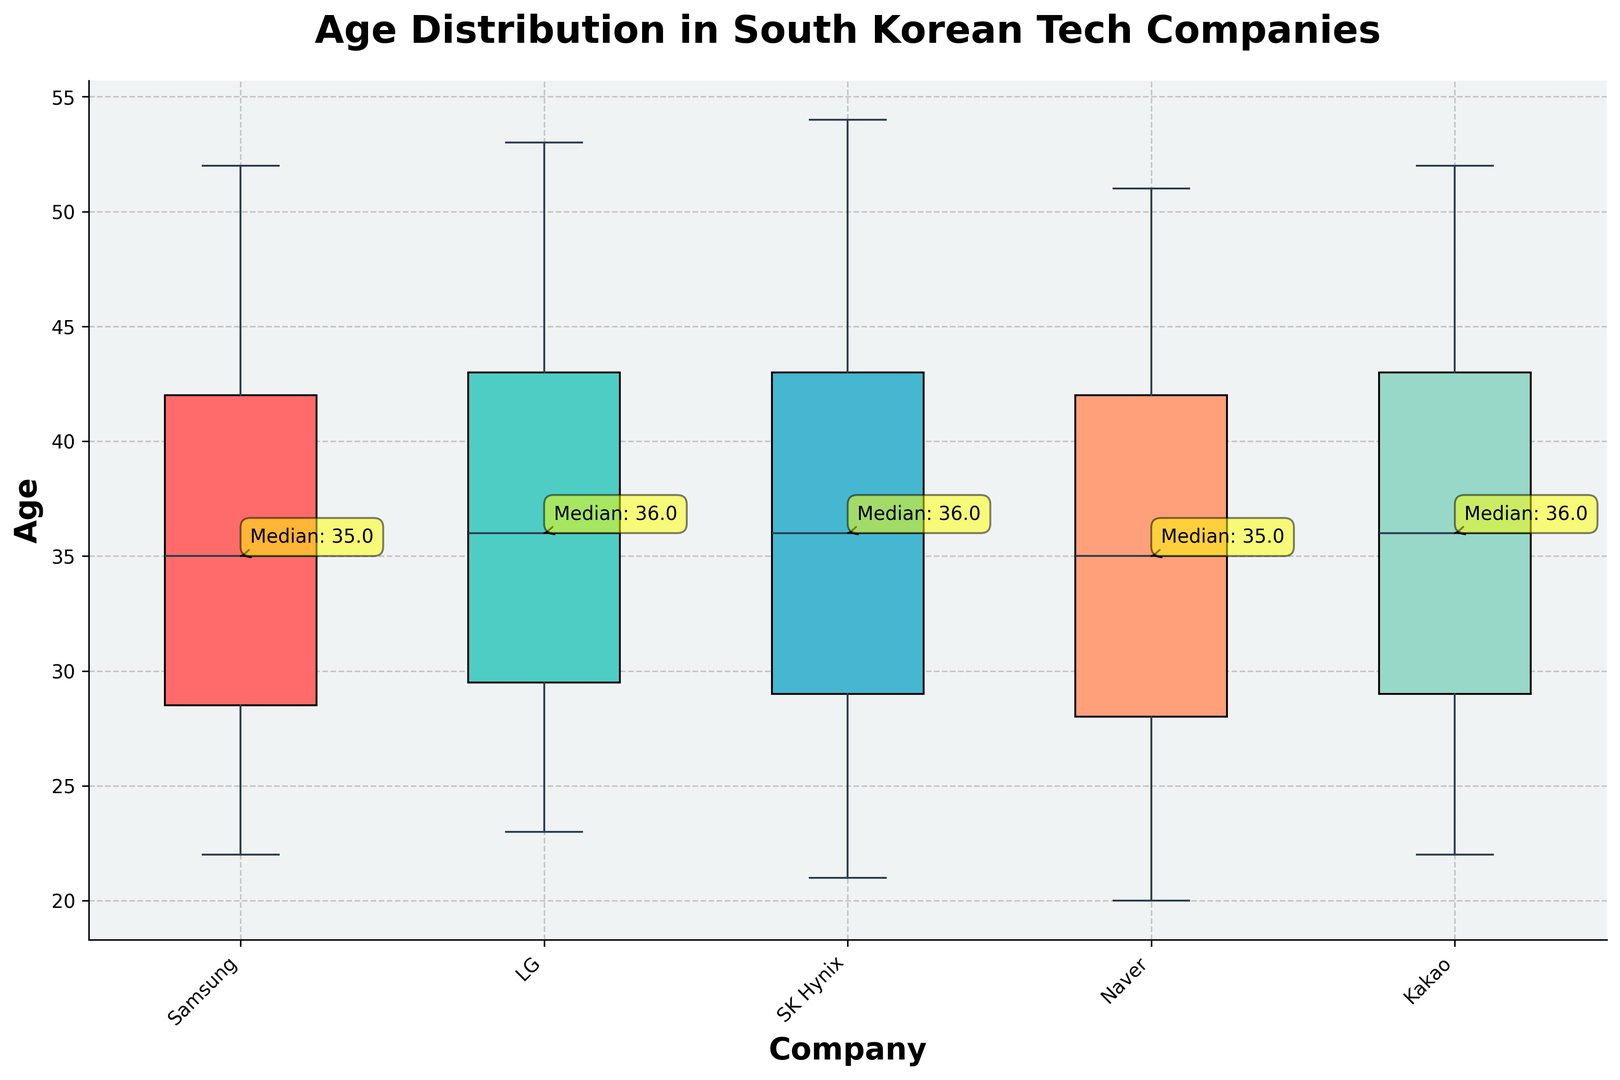Which company has the oldest median age for employees? To answer, look at the annotated median values for each company. SK Hynix has the highest median annotation.
Answer: SK Hynix What is the median age of employees at Samsung? Check the annotation box associated with Samsung in the box plot for the median.
Answer: 37 Compare the interquartile range (IQR) of Samsung and Kakao. Which has a larger IQR? The IQR is shown by the box height. Samsung's box is taller/longer than Kakao's, indicating a larger IQR.
Answer: Samsung How does the median age of LG employees compare to that of Naver employees? The median ages are annotated, with LG having a slightly higher median compared to Naver.
Answer: LG's median is higher Which company has the youngest median age for employees? Check the annotated median values, with Naver having the lowest median age.
Answer: Naver What is the range of ages for employees at SK Hynix? The range is the difference between the highest and lowest whisker lengths. The highest age is 54, and the lowest is 21.
Answer: 33 How many companies have a median age greater than 35? Refer to the annotated median values; companies having medians over 35 are Samsung, LG, and SK Hynix.
Answer: 3 Which company has the most narrowly distributed ages (smallest IQR)? Look at box lengths, with Naver having the shortest box.
Answer: Naver Compare the maximum age observed at Samsung against Kakao. Which is higher? Check the maximum whiskers. Samsung's highest value is 52, while Kakao's is also 52.
Answer: Equal If you average the medians of all companies, what value do you get? The medians are 37 (Samsung), 38.5 (LG), 37 (Naver), 37 (SK Hynix), 38 (Kakao). Summing: 37 + 38.5 + 37 + 37 + 38 = 187.5, and averaging: 187.5 / 5.
Answer: 37.5 